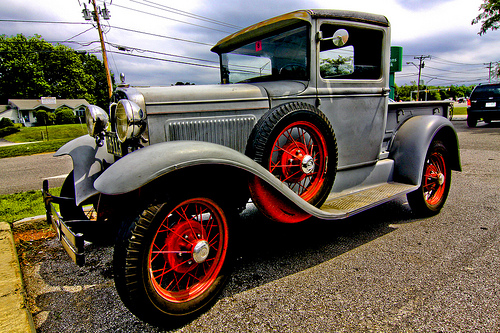<image>
Can you confirm if the wheel is above the road? Yes. The wheel is positioned above the road in the vertical space, higher up in the scene. 